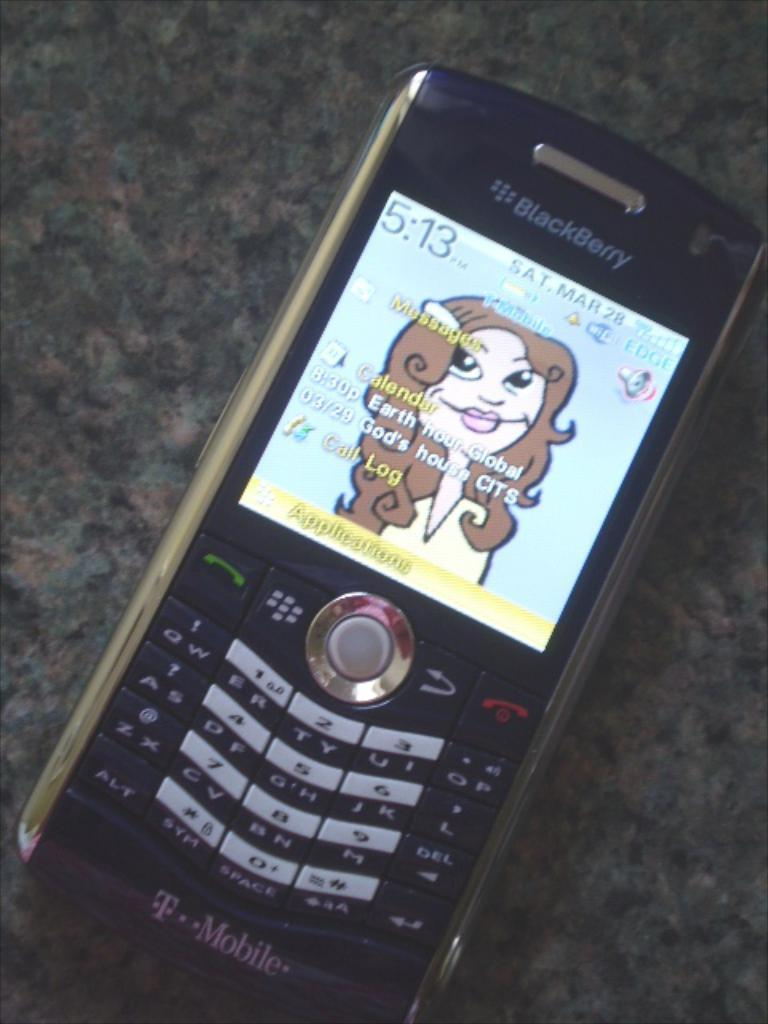<image>
Offer a succinct explanation of the picture presented. An older blackberry phone made by T Mobile lies on a gray table. 